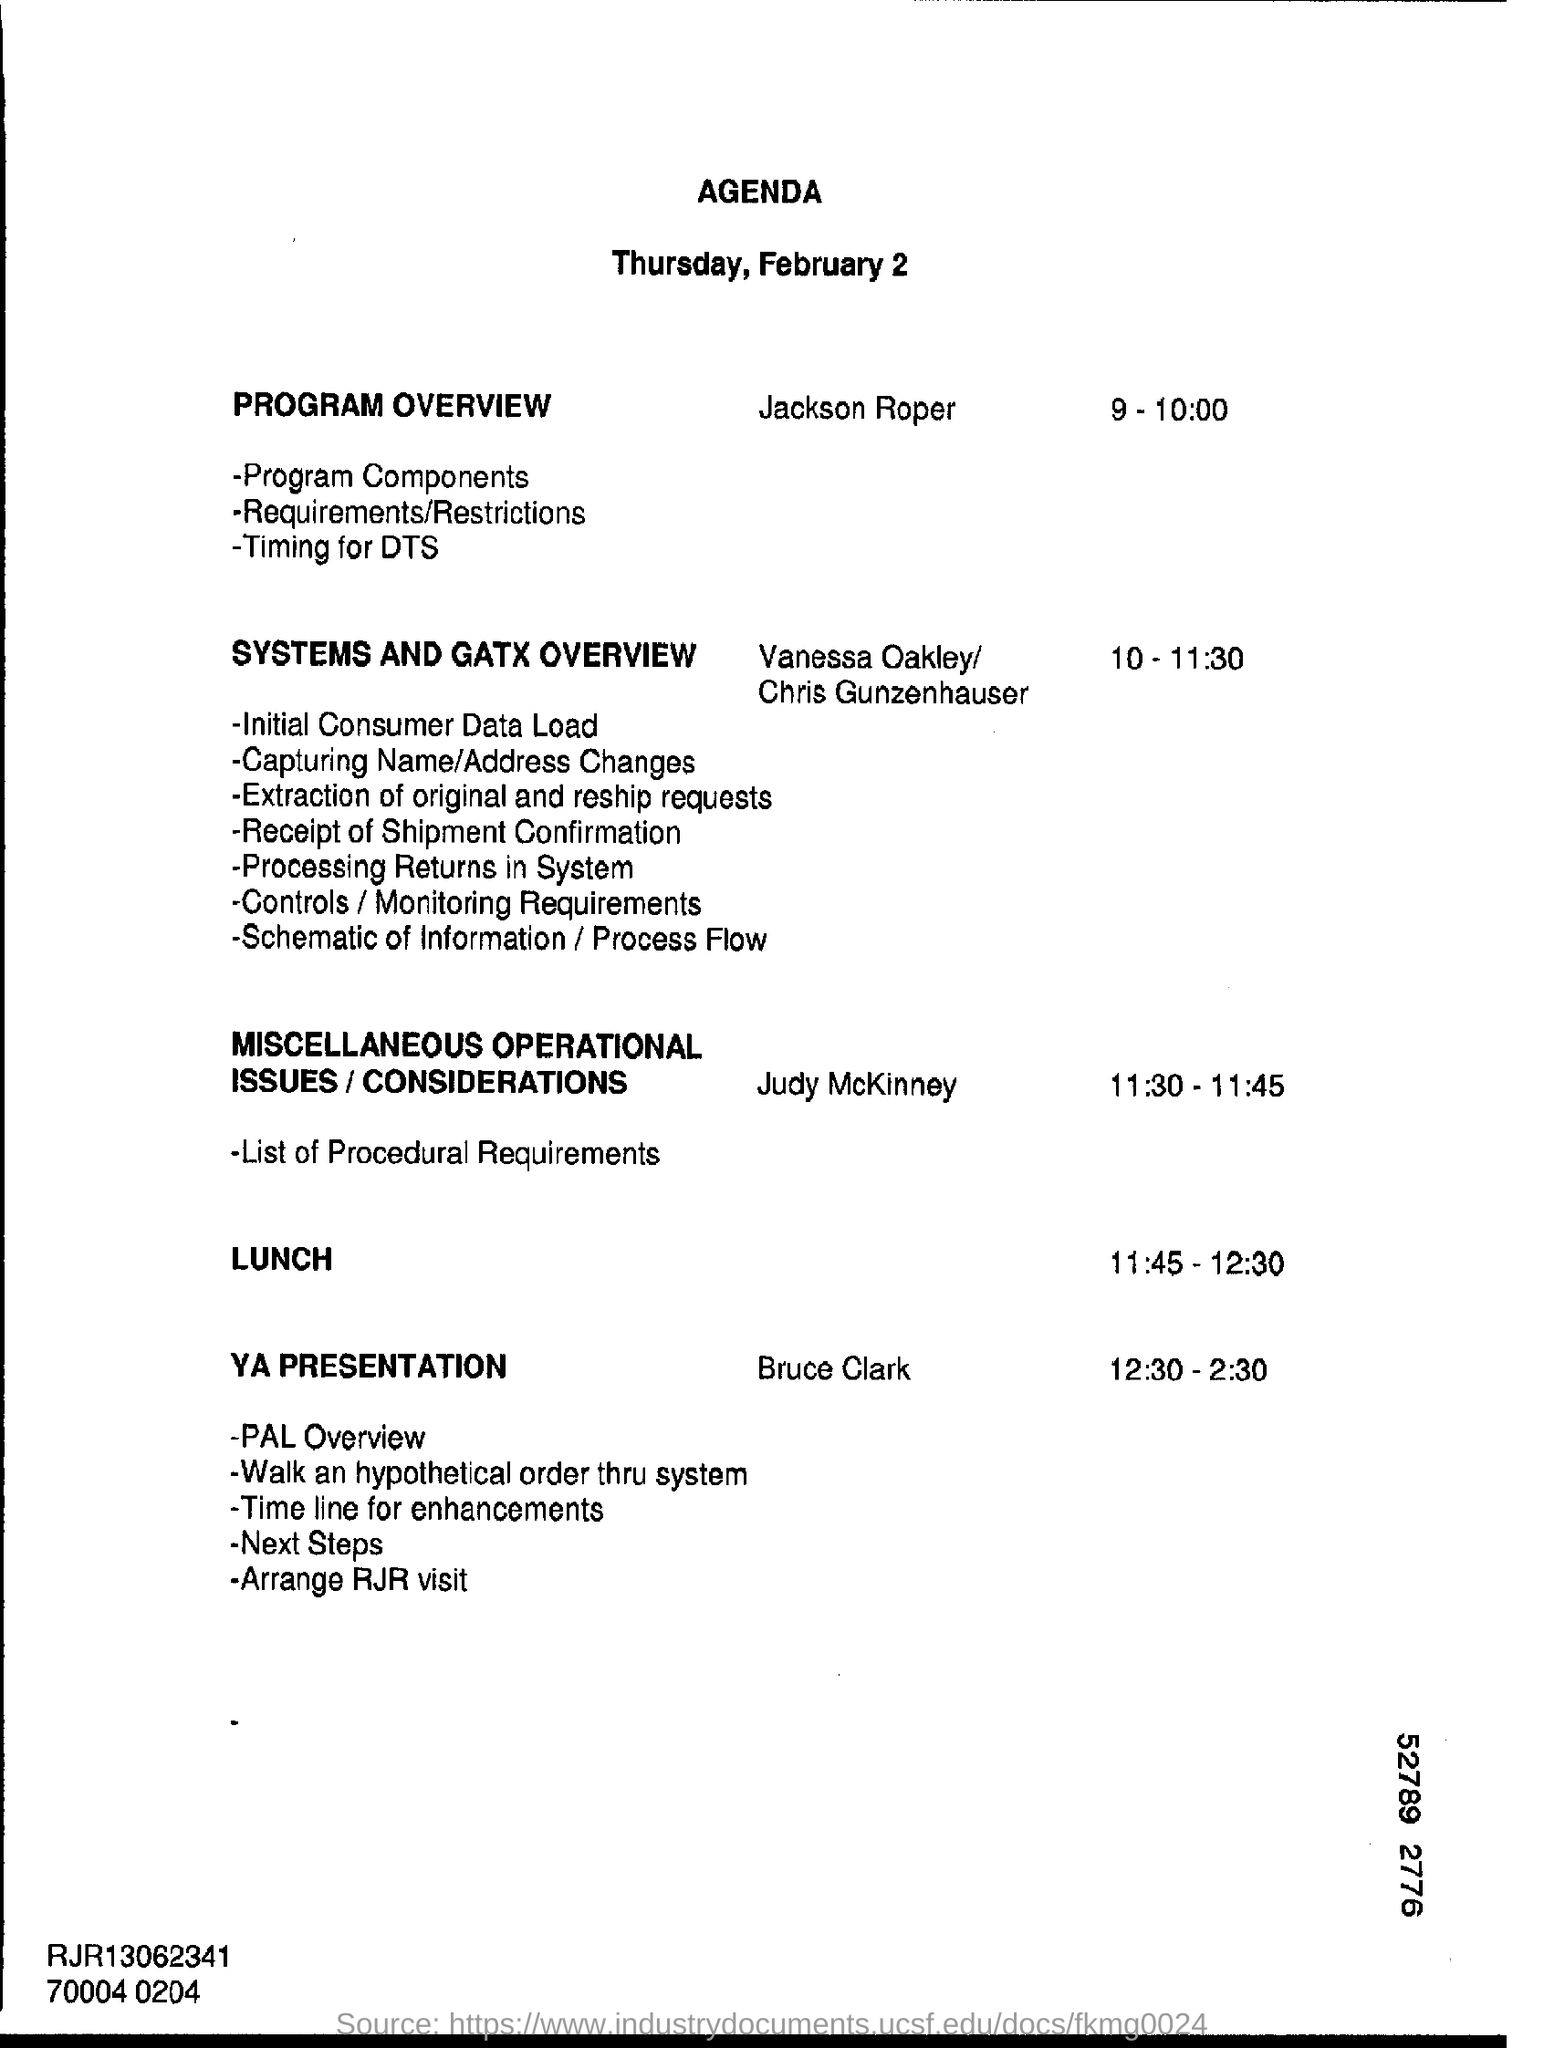List a handful of essential elements in this visual. The date mentioned at the top of the document is February 2021. The lunch time is from 11:45 to 12:30. The time for the YA presentation is from 12:30 PM to 2:30 PM. 